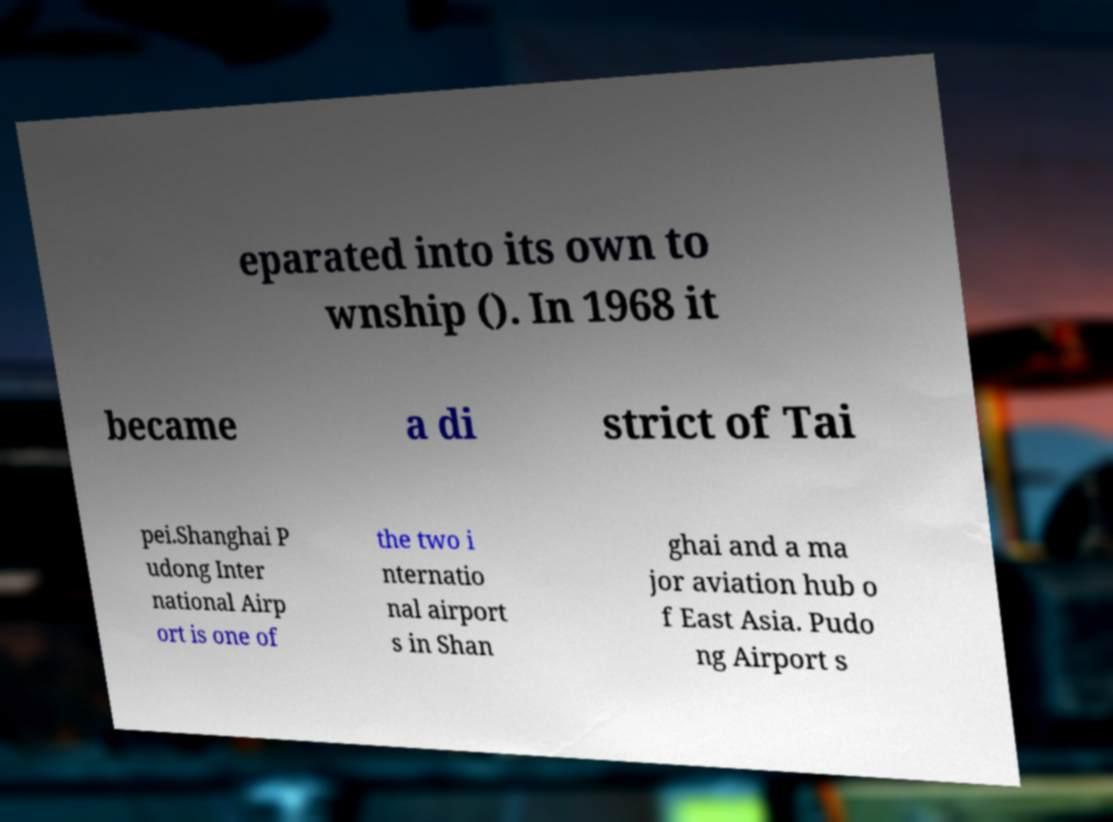For documentation purposes, I need the text within this image transcribed. Could you provide that? eparated into its own to wnship (). In 1968 it became a di strict of Tai pei.Shanghai P udong Inter national Airp ort is one of the two i nternatio nal airport s in Shan ghai and a ma jor aviation hub o f East Asia. Pudo ng Airport s 